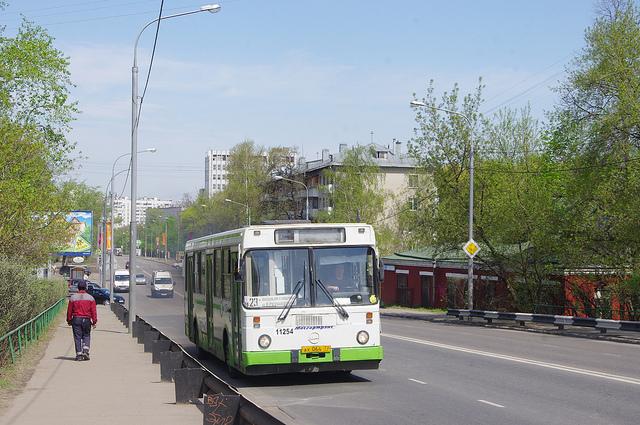How many colors is this bus?
Concise answer only. 2. How far is the bus stop?
Answer briefly. 10 feet. Is there a sidewalk next to the street?
Write a very short answer. Yes. 